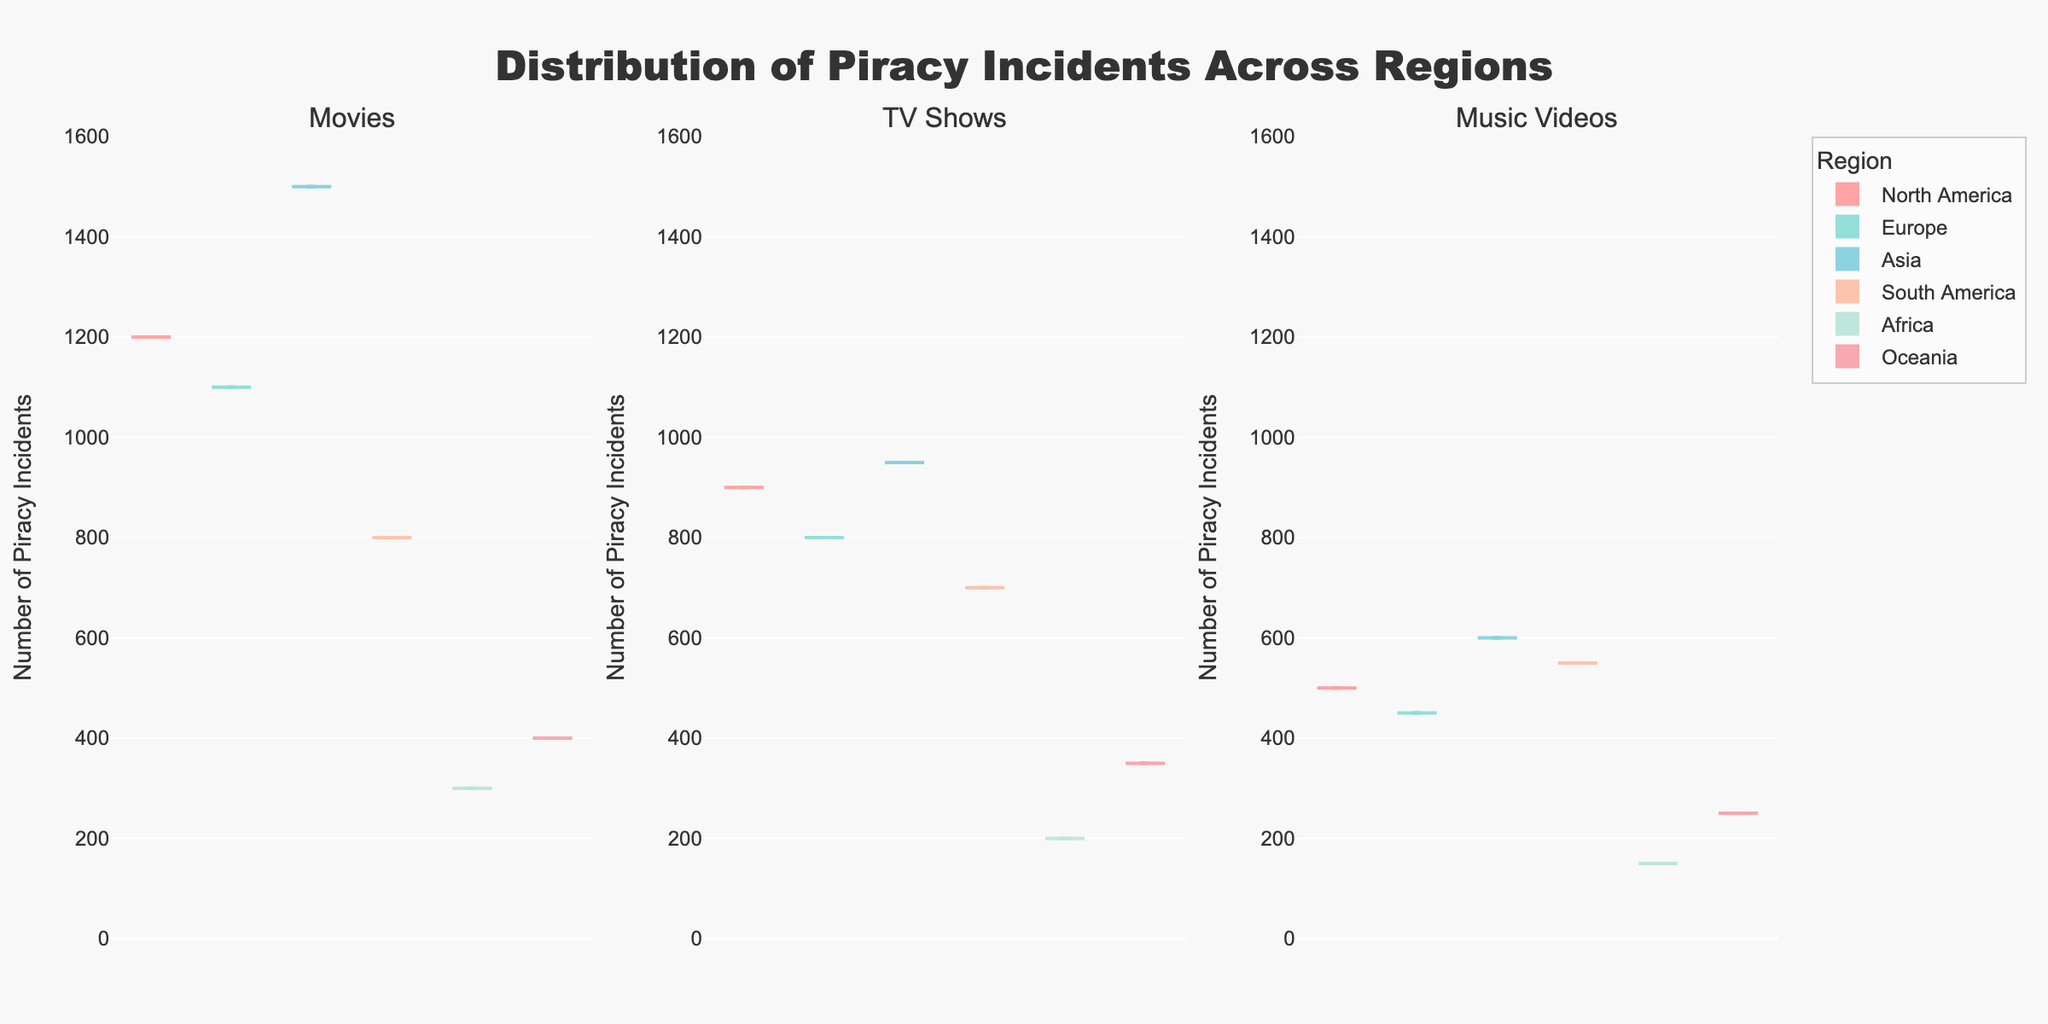What is the title of the figure? The title is typically located at the top of the figure. Upon inspection, it reads "Distribution of Piracy Incidents Across Regions."
Answer: Distribution of Piracy Incidents Across Regions What does the y-axis represent? The y-axis usually indicates the measure being compared across different categories. In this figure, it is labeled as "Number of Piracy Incidents."
Answer: Number of Piracy Incidents Which content type has the most piracy incidents in Asia? By examining the subplots and focusing on the one for Asia, we compare the mean line or the density height for each content type. Movies have the highest density.
Answer: Movies Which region reports the least piracy incidents for Music Videos? We find the Music Videos subplot and compare all regions. Africa has the lowest density indicating fewer piracy incidents.
Answer: Africa What is the range of piracy incidents for TV Shows in Europe? Locate the TV Shows subplot, and specifically Europe. The range extends from the minimum to the maximum values that the box plots cover.
Answer: 200-800 Which region has the widest range of piracy incidents for Movies? By examining the Movie subplots and assessing the interquartile ranges (box lengths), Asia appears to have the widest range.
Answer: Asia In Oceania, which content type has the lowest number of piracy incidents on average? For Oceania's subplots, compare the mean lines across content types. Music Videos have the lowest average incidents.
Answer: Music Videos Which regions have a higher number of piracy incidents for Movies compared to TV Shows? For each region in the Movies and TV Shows subplots, compare the height or value. North America, Europe, and Asia have higher incidents for Movies than TV Shows.
Answer: North America, Europe, Asia What type of content experiences the broadest spread of piracy incidents in South America? In South America's subplots, analyze the box-and-whisker plots to determine the spread. Movies show the broadest spread.
Answer: Movies Which region shows relatively consistent piracy incidents across all content types? By looking for similar box plot lengths among all content types in any region, North America displays relative consistency across Movies, TV Shows, and Music Videos.
Answer: North America 